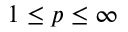<formula> <loc_0><loc_0><loc_500><loc_500>1 \leq p \leq \infty</formula> 